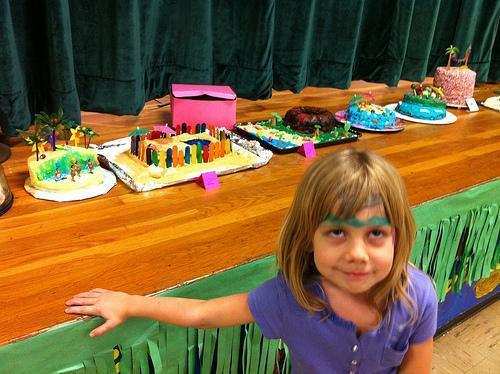How many girls in the photo?
Give a very brief answer. 1. 